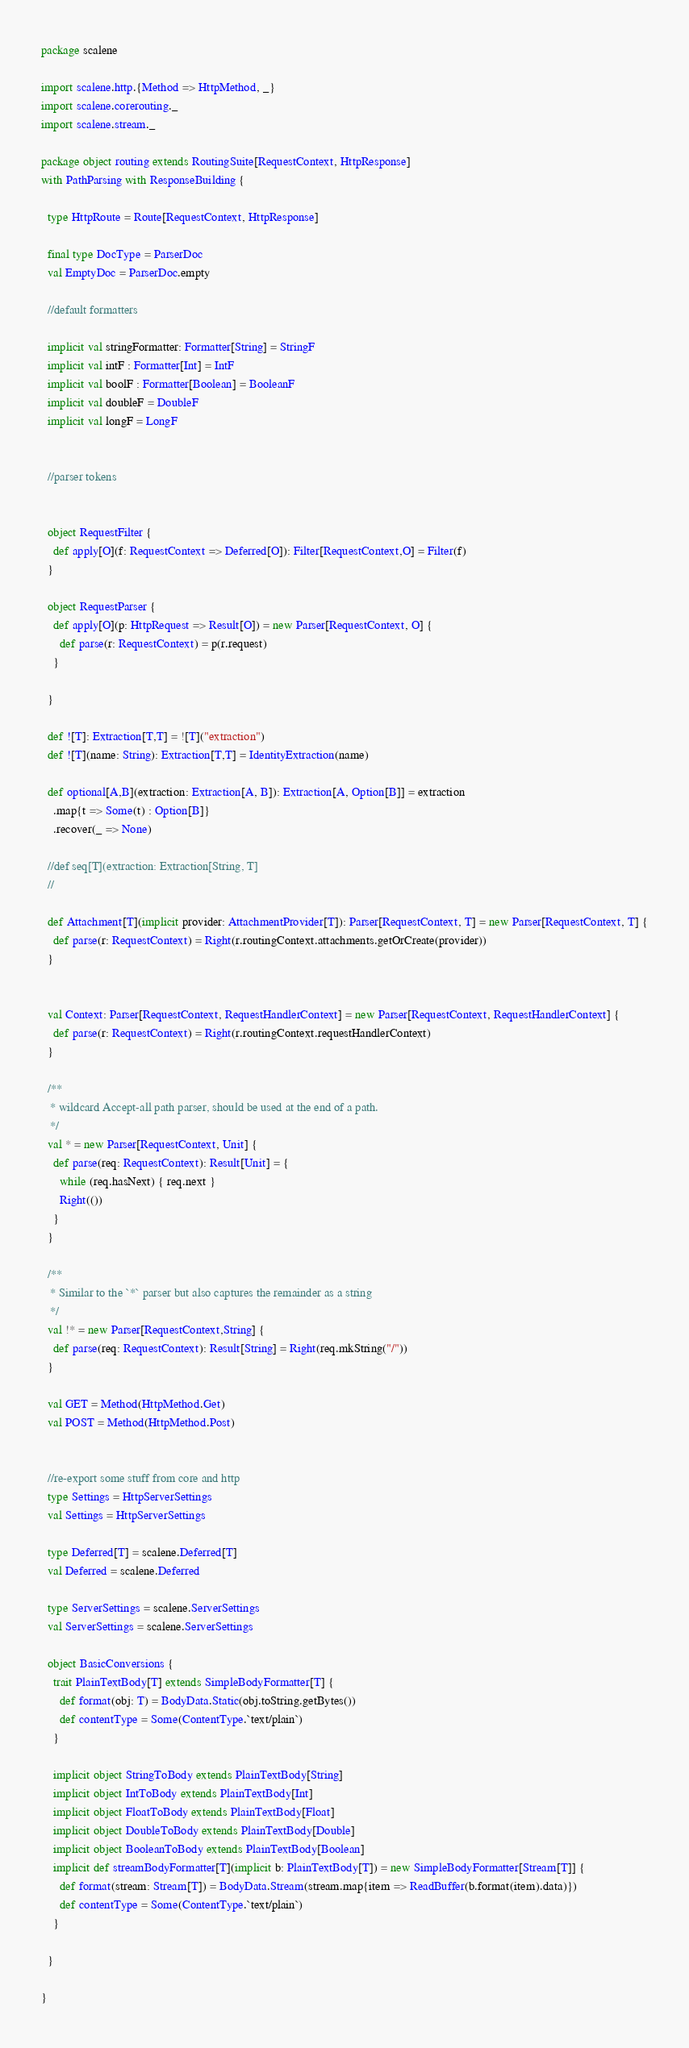<code> <loc_0><loc_0><loc_500><loc_500><_Scala_>package scalene

import scalene.http.{Method => HttpMethod, _}
import scalene.corerouting._
import scalene.stream._

package object routing extends RoutingSuite[RequestContext, HttpResponse]
with PathParsing with ResponseBuilding {

  type HttpRoute = Route[RequestContext, HttpResponse]

  final type DocType = ParserDoc
  val EmptyDoc = ParserDoc.empty

  //default formatters

  implicit val stringFormatter: Formatter[String] = StringF
  implicit val intF : Formatter[Int] = IntF
  implicit val boolF : Formatter[Boolean] = BooleanF
  implicit val doubleF = DoubleF
  implicit val longF = LongF


  //parser tokens


  object RequestFilter {
    def apply[O](f: RequestContext => Deferred[O]): Filter[RequestContext,O] = Filter(f)
  }

  object RequestParser {
    def apply[O](p: HttpRequest => Result[O]) = new Parser[RequestContext, O] {
      def parse(r: RequestContext) = p(r.request)
    }

  }

  def ![T]: Extraction[T,T] = ![T]("extraction")
  def ![T](name: String): Extraction[T,T] = IdentityExtraction(name) 

  def optional[A,B](extraction: Extraction[A, B]): Extraction[A, Option[B]] = extraction
    .map{t => Some(t) : Option[B]}
    .recover(_ => None)

  //def seq[T](extraction: Extraction[String, T]
  //

  def Attachment[T](implicit provider: AttachmentProvider[T]): Parser[RequestContext, T] = new Parser[RequestContext, T] {
    def parse(r: RequestContext) = Right(r.routingContext.attachments.getOrCreate(provider))
  }


  val Context: Parser[RequestContext, RequestHandlerContext] = new Parser[RequestContext, RequestHandlerContext] {
    def parse(r: RequestContext) = Right(r.routingContext.requestHandlerContext)
  }

  /**
   * wildcard Accept-all path parser, should be used at the end of a path.
   */
  val * = new Parser[RequestContext, Unit] {
    def parse(req: RequestContext): Result[Unit] = {
      while (req.hasNext) { req.next }
      Right(())
    }
  }

  /**
   * Similar to the `*` parser but also captures the remainder as a string
   */
  val !* = new Parser[RequestContext,String] {
    def parse(req: RequestContext): Result[String] = Right(req.mkString("/"))
  }

  val GET = Method(HttpMethod.Get)
  val POST = Method(HttpMethod.Post)


  //re-export some stuff from core and http
  type Settings = HttpServerSettings
  val Settings = HttpServerSettings

  type Deferred[T] = scalene.Deferred[T]
  val Deferred = scalene.Deferred

  type ServerSettings = scalene.ServerSettings
  val ServerSettings = scalene.ServerSettings

  object BasicConversions {
    trait PlainTextBody[T] extends SimpleBodyFormatter[T] {
      def format(obj: T) = BodyData.Static(obj.toString.getBytes())
      def contentType = Some(ContentType.`text/plain`)
    }

    implicit object StringToBody extends PlainTextBody[String] 
    implicit object IntToBody extends PlainTextBody[Int] 
    implicit object FloatToBody extends PlainTextBody[Float] 
    implicit object DoubleToBody extends PlainTextBody[Double] 
    implicit object BooleanToBody extends PlainTextBody[Boolean] 
    implicit def streamBodyFormatter[T](implicit b: PlainTextBody[T]) = new SimpleBodyFormatter[Stream[T]] {
      def format(stream: Stream[T]) = BodyData.Stream(stream.map{item => ReadBuffer(b.format(item).data)})
      def contentType = Some(ContentType.`text/plain`)
    }

  }

}
</code> 